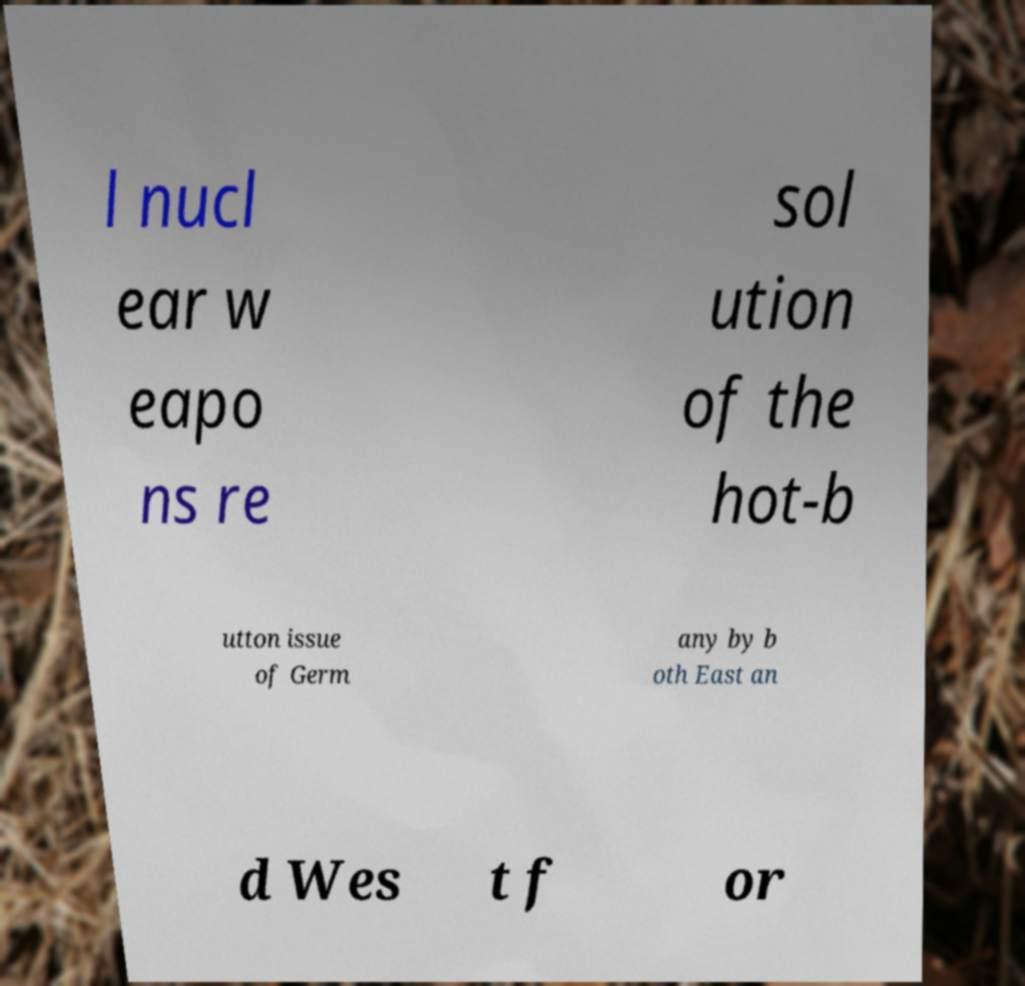Could you extract and type out the text from this image? l nucl ear w eapo ns re sol ution of the hot-b utton issue of Germ any by b oth East an d Wes t f or 